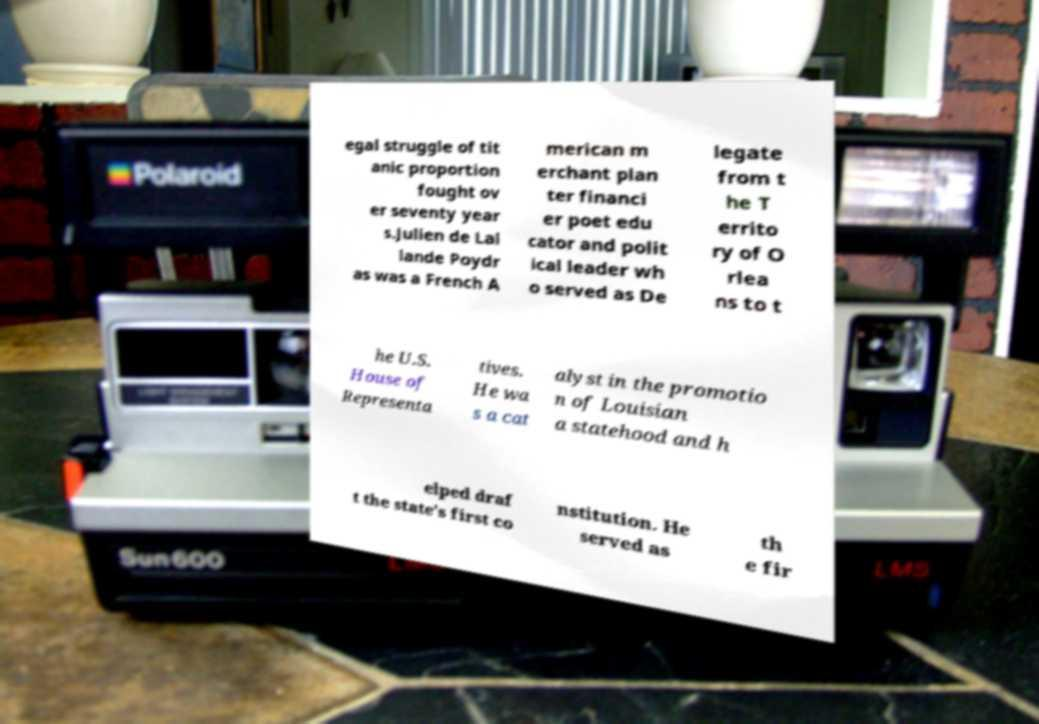Can you accurately transcribe the text from the provided image for me? egal struggle of tit anic proportion fought ov er seventy year s.Julien de Lal lande Poydr as was a French A merican m erchant plan ter financi er poet edu cator and polit ical leader wh o served as De legate from t he T errito ry of O rlea ns to t he U.S. House of Representa tives. He wa s a cat alyst in the promotio n of Louisian a statehood and h elped draf t the state's first co nstitution. He served as th e fir 